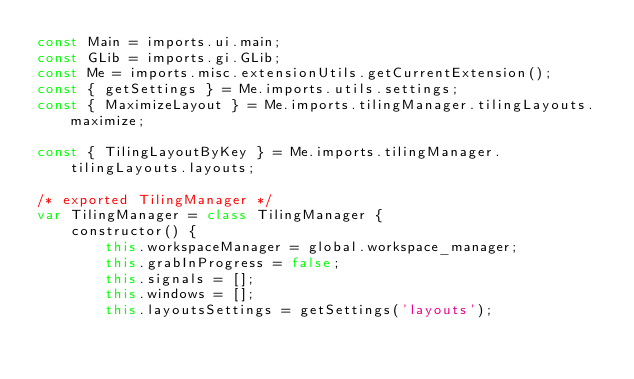Convert code to text. <code><loc_0><loc_0><loc_500><loc_500><_JavaScript_>const Main = imports.ui.main;
const GLib = imports.gi.GLib;
const Me = imports.misc.extensionUtils.getCurrentExtension();
const { getSettings } = Me.imports.utils.settings;
const { MaximizeLayout } = Me.imports.tilingManager.tilingLayouts.maximize;

const { TilingLayoutByKey } = Me.imports.tilingManager.tilingLayouts.layouts;

/* exported TilingManager */
var TilingManager = class TilingManager {
    constructor() {
        this.workspaceManager = global.workspace_manager;
        this.grabInProgress = false;
        this.signals = [];
        this.windows = [];
        this.layoutsSettings = getSettings('layouts');</code> 